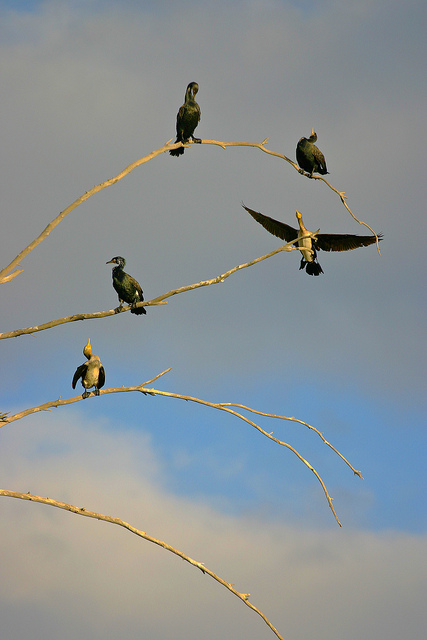How many of the birds have their wings spread wide open? Among the five birds, one displays its wings majestically spread wide open; a captivating moment frozen in time. 